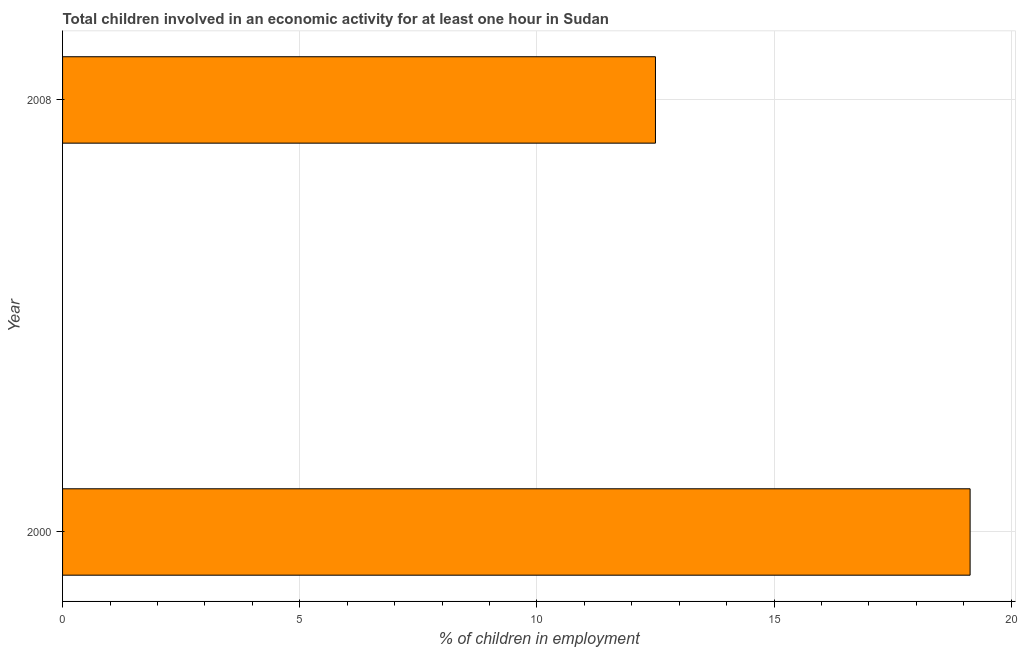Does the graph contain grids?
Ensure brevity in your answer.  Yes. What is the title of the graph?
Provide a succinct answer. Total children involved in an economic activity for at least one hour in Sudan. What is the label or title of the X-axis?
Make the answer very short. % of children in employment. What is the label or title of the Y-axis?
Provide a succinct answer. Year. Across all years, what is the maximum percentage of children in employment?
Offer a terse response. 19.13. What is the sum of the percentage of children in employment?
Offer a terse response. 31.63. What is the difference between the percentage of children in employment in 2000 and 2008?
Offer a very short reply. 6.63. What is the average percentage of children in employment per year?
Your answer should be compact. 15.82. What is the median percentage of children in employment?
Provide a succinct answer. 15.82. What is the ratio of the percentage of children in employment in 2000 to that in 2008?
Your answer should be compact. 1.53. How many bars are there?
Provide a short and direct response. 2. How many years are there in the graph?
Provide a succinct answer. 2. What is the difference between two consecutive major ticks on the X-axis?
Provide a succinct answer. 5. Are the values on the major ticks of X-axis written in scientific E-notation?
Offer a terse response. No. What is the % of children in employment in 2000?
Your response must be concise. 19.13. What is the % of children in employment of 2008?
Your answer should be very brief. 12.5. What is the difference between the % of children in employment in 2000 and 2008?
Offer a very short reply. 6.63. What is the ratio of the % of children in employment in 2000 to that in 2008?
Give a very brief answer. 1.53. 